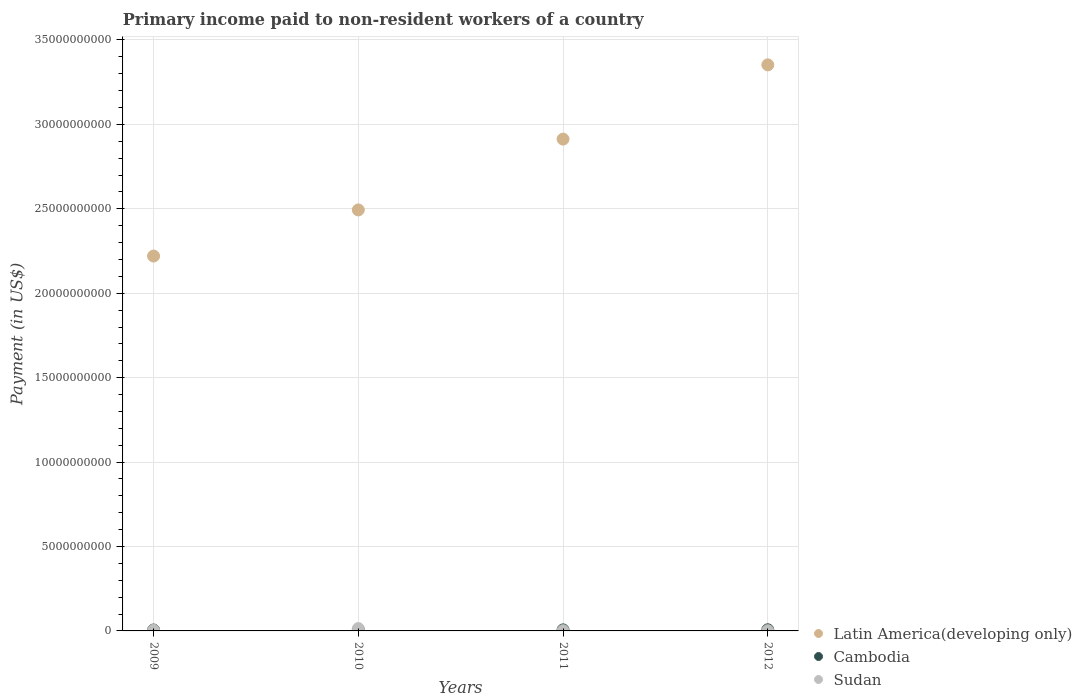Is the number of dotlines equal to the number of legend labels?
Ensure brevity in your answer.  Yes. What is the amount paid to workers in Sudan in 2011?
Keep it short and to the point. 1.35e+07. Across all years, what is the maximum amount paid to workers in Sudan?
Ensure brevity in your answer.  1.39e+08. Across all years, what is the minimum amount paid to workers in Cambodia?
Your answer should be very brief. 5.55e+07. What is the total amount paid to workers in Sudan in the graph?
Offer a very short reply. 2.03e+08. What is the difference between the amount paid to workers in Sudan in 2009 and that in 2010?
Keep it short and to the point. -1.02e+08. What is the difference between the amount paid to workers in Cambodia in 2010 and the amount paid to workers in Sudan in 2012?
Give a very brief answer. 4.44e+07. What is the average amount paid to workers in Cambodia per year?
Make the answer very short. 6.08e+07. In the year 2010, what is the difference between the amount paid to workers in Sudan and amount paid to workers in Latin America(developing only)?
Ensure brevity in your answer.  -2.48e+1. In how many years, is the amount paid to workers in Sudan greater than 9000000000 US$?
Your answer should be compact. 0. What is the ratio of the amount paid to workers in Cambodia in 2010 to that in 2011?
Provide a succinct answer. 0.96. Is the amount paid to workers in Cambodia in 2009 less than that in 2011?
Offer a very short reply. Yes. What is the difference between the highest and the second highest amount paid to workers in Sudan?
Your answer should be very brief. 1.02e+08. What is the difference between the highest and the lowest amount paid to workers in Sudan?
Give a very brief answer. 1.25e+08. Does the amount paid to workers in Sudan monotonically increase over the years?
Provide a short and direct response. No. How many dotlines are there?
Your answer should be compact. 3. What is the difference between two consecutive major ticks on the Y-axis?
Your response must be concise. 5.00e+09. Are the values on the major ticks of Y-axis written in scientific E-notation?
Offer a terse response. No. Does the graph contain any zero values?
Your response must be concise. No. Where does the legend appear in the graph?
Keep it short and to the point. Bottom right. How are the legend labels stacked?
Offer a very short reply. Vertical. What is the title of the graph?
Make the answer very short. Primary income paid to non-resident workers of a country. What is the label or title of the X-axis?
Make the answer very short. Years. What is the label or title of the Y-axis?
Offer a very short reply. Payment (in US$). What is the Payment (in US$) of Latin America(developing only) in 2009?
Keep it short and to the point. 2.22e+1. What is the Payment (in US$) in Cambodia in 2009?
Offer a terse response. 5.55e+07. What is the Payment (in US$) of Sudan in 2009?
Ensure brevity in your answer.  3.67e+07. What is the Payment (in US$) of Latin America(developing only) in 2010?
Offer a very short reply. 2.49e+1. What is the Payment (in US$) of Cambodia in 2010?
Make the answer very short. 5.87e+07. What is the Payment (in US$) of Sudan in 2010?
Your response must be concise. 1.39e+08. What is the Payment (in US$) in Latin America(developing only) in 2011?
Give a very brief answer. 2.91e+1. What is the Payment (in US$) in Cambodia in 2011?
Ensure brevity in your answer.  6.13e+07. What is the Payment (in US$) of Sudan in 2011?
Keep it short and to the point. 1.35e+07. What is the Payment (in US$) in Latin America(developing only) in 2012?
Provide a short and direct response. 3.35e+1. What is the Payment (in US$) in Cambodia in 2012?
Ensure brevity in your answer.  6.76e+07. What is the Payment (in US$) of Sudan in 2012?
Keep it short and to the point. 1.43e+07. Across all years, what is the maximum Payment (in US$) of Latin America(developing only)?
Ensure brevity in your answer.  3.35e+1. Across all years, what is the maximum Payment (in US$) of Cambodia?
Ensure brevity in your answer.  6.76e+07. Across all years, what is the maximum Payment (in US$) in Sudan?
Keep it short and to the point. 1.39e+08. Across all years, what is the minimum Payment (in US$) in Latin America(developing only)?
Provide a succinct answer. 2.22e+1. Across all years, what is the minimum Payment (in US$) in Cambodia?
Keep it short and to the point. 5.55e+07. Across all years, what is the minimum Payment (in US$) in Sudan?
Keep it short and to the point. 1.35e+07. What is the total Payment (in US$) of Latin America(developing only) in the graph?
Make the answer very short. 1.10e+11. What is the total Payment (in US$) of Cambodia in the graph?
Provide a succinct answer. 2.43e+08. What is the total Payment (in US$) of Sudan in the graph?
Offer a terse response. 2.03e+08. What is the difference between the Payment (in US$) of Latin America(developing only) in 2009 and that in 2010?
Your response must be concise. -2.73e+09. What is the difference between the Payment (in US$) of Cambodia in 2009 and that in 2010?
Provide a succinct answer. -3.15e+06. What is the difference between the Payment (in US$) of Sudan in 2009 and that in 2010?
Offer a very short reply. -1.02e+08. What is the difference between the Payment (in US$) in Latin America(developing only) in 2009 and that in 2011?
Offer a terse response. -6.93e+09. What is the difference between the Payment (in US$) in Cambodia in 2009 and that in 2011?
Offer a very short reply. -5.77e+06. What is the difference between the Payment (in US$) of Sudan in 2009 and that in 2011?
Your response must be concise. 2.32e+07. What is the difference between the Payment (in US$) of Latin America(developing only) in 2009 and that in 2012?
Your answer should be compact. -1.13e+1. What is the difference between the Payment (in US$) in Cambodia in 2009 and that in 2012?
Keep it short and to the point. -1.21e+07. What is the difference between the Payment (in US$) of Sudan in 2009 and that in 2012?
Provide a short and direct response. 2.25e+07. What is the difference between the Payment (in US$) in Latin America(developing only) in 2010 and that in 2011?
Your answer should be compact. -4.19e+09. What is the difference between the Payment (in US$) of Cambodia in 2010 and that in 2011?
Provide a short and direct response. -2.62e+06. What is the difference between the Payment (in US$) in Sudan in 2010 and that in 2011?
Offer a very short reply. 1.25e+08. What is the difference between the Payment (in US$) of Latin America(developing only) in 2010 and that in 2012?
Your response must be concise. -8.59e+09. What is the difference between the Payment (in US$) in Cambodia in 2010 and that in 2012?
Provide a succinct answer. -8.93e+06. What is the difference between the Payment (in US$) of Sudan in 2010 and that in 2012?
Provide a short and direct response. 1.24e+08. What is the difference between the Payment (in US$) in Latin America(developing only) in 2011 and that in 2012?
Ensure brevity in your answer.  -4.40e+09. What is the difference between the Payment (in US$) in Cambodia in 2011 and that in 2012?
Keep it short and to the point. -6.31e+06. What is the difference between the Payment (in US$) in Sudan in 2011 and that in 2012?
Make the answer very short. -7.31e+05. What is the difference between the Payment (in US$) in Latin America(developing only) in 2009 and the Payment (in US$) in Cambodia in 2010?
Ensure brevity in your answer.  2.21e+1. What is the difference between the Payment (in US$) in Latin America(developing only) in 2009 and the Payment (in US$) in Sudan in 2010?
Provide a short and direct response. 2.21e+1. What is the difference between the Payment (in US$) in Cambodia in 2009 and the Payment (in US$) in Sudan in 2010?
Your answer should be very brief. -8.30e+07. What is the difference between the Payment (in US$) in Latin America(developing only) in 2009 and the Payment (in US$) in Cambodia in 2011?
Provide a succinct answer. 2.21e+1. What is the difference between the Payment (in US$) of Latin America(developing only) in 2009 and the Payment (in US$) of Sudan in 2011?
Your answer should be compact. 2.22e+1. What is the difference between the Payment (in US$) of Cambodia in 2009 and the Payment (in US$) of Sudan in 2011?
Give a very brief answer. 4.20e+07. What is the difference between the Payment (in US$) of Latin America(developing only) in 2009 and the Payment (in US$) of Cambodia in 2012?
Your answer should be very brief. 2.21e+1. What is the difference between the Payment (in US$) in Latin America(developing only) in 2009 and the Payment (in US$) in Sudan in 2012?
Your answer should be compact. 2.22e+1. What is the difference between the Payment (in US$) in Cambodia in 2009 and the Payment (in US$) in Sudan in 2012?
Your answer should be compact. 4.13e+07. What is the difference between the Payment (in US$) in Latin America(developing only) in 2010 and the Payment (in US$) in Cambodia in 2011?
Ensure brevity in your answer.  2.49e+1. What is the difference between the Payment (in US$) of Latin America(developing only) in 2010 and the Payment (in US$) of Sudan in 2011?
Your response must be concise. 2.49e+1. What is the difference between the Payment (in US$) of Cambodia in 2010 and the Payment (in US$) of Sudan in 2011?
Give a very brief answer. 4.52e+07. What is the difference between the Payment (in US$) in Latin America(developing only) in 2010 and the Payment (in US$) in Cambodia in 2012?
Make the answer very short. 2.49e+1. What is the difference between the Payment (in US$) in Latin America(developing only) in 2010 and the Payment (in US$) in Sudan in 2012?
Your answer should be very brief. 2.49e+1. What is the difference between the Payment (in US$) of Cambodia in 2010 and the Payment (in US$) of Sudan in 2012?
Offer a terse response. 4.44e+07. What is the difference between the Payment (in US$) in Latin America(developing only) in 2011 and the Payment (in US$) in Cambodia in 2012?
Give a very brief answer. 2.91e+1. What is the difference between the Payment (in US$) in Latin America(developing only) in 2011 and the Payment (in US$) in Sudan in 2012?
Make the answer very short. 2.91e+1. What is the difference between the Payment (in US$) of Cambodia in 2011 and the Payment (in US$) of Sudan in 2012?
Give a very brief answer. 4.70e+07. What is the average Payment (in US$) in Latin America(developing only) per year?
Ensure brevity in your answer.  2.74e+1. What is the average Payment (in US$) in Cambodia per year?
Keep it short and to the point. 6.08e+07. What is the average Payment (in US$) in Sudan per year?
Keep it short and to the point. 5.08e+07. In the year 2009, what is the difference between the Payment (in US$) of Latin America(developing only) and Payment (in US$) of Cambodia?
Make the answer very short. 2.21e+1. In the year 2009, what is the difference between the Payment (in US$) in Latin America(developing only) and Payment (in US$) in Sudan?
Keep it short and to the point. 2.22e+1. In the year 2009, what is the difference between the Payment (in US$) in Cambodia and Payment (in US$) in Sudan?
Make the answer very short. 1.88e+07. In the year 2010, what is the difference between the Payment (in US$) in Latin America(developing only) and Payment (in US$) in Cambodia?
Provide a short and direct response. 2.49e+1. In the year 2010, what is the difference between the Payment (in US$) in Latin America(developing only) and Payment (in US$) in Sudan?
Make the answer very short. 2.48e+1. In the year 2010, what is the difference between the Payment (in US$) in Cambodia and Payment (in US$) in Sudan?
Ensure brevity in your answer.  -7.99e+07. In the year 2011, what is the difference between the Payment (in US$) of Latin America(developing only) and Payment (in US$) of Cambodia?
Your answer should be compact. 2.91e+1. In the year 2011, what is the difference between the Payment (in US$) in Latin America(developing only) and Payment (in US$) in Sudan?
Provide a succinct answer. 2.91e+1. In the year 2011, what is the difference between the Payment (in US$) in Cambodia and Payment (in US$) in Sudan?
Offer a terse response. 4.78e+07. In the year 2012, what is the difference between the Payment (in US$) of Latin America(developing only) and Payment (in US$) of Cambodia?
Make the answer very short. 3.35e+1. In the year 2012, what is the difference between the Payment (in US$) of Latin America(developing only) and Payment (in US$) of Sudan?
Ensure brevity in your answer.  3.35e+1. In the year 2012, what is the difference between the Payment (in US$) of Cambodia and Payment (in US$) of Sudan?
Provide a succinct answer. 5.33e+07. What is the ratio of the Payment (in US$) in Latin America(developing only) in 2009 to that in 2010?
Make the answer very short. 0.89. What is the ratio of the Payment (in US$) of Cambodia in 2009 to that in 2010?
Provide a short and direct response. 0.95. What is the ratio of the Payment (in US$) in Sudan in 2009 to that in 2010?
Your response must be concise. 0.27. What is the ratio of the Payment (in US$) of Latin America(developing only) in 2009 to that in 2011?
Provide a succinct answer. 0.76. What is the ratio of the Payment (in US$) of Cambodia in 2009 to that in 2011?
Keep it short and to the point. 0.91. What is the ratio of the Payment (in US$) of Sudan in 2009 to that in 2011?
Your answer should be compact. 2.71. What is the ratio of the Payment (in US$) of Latin America(developing only) in 2009 to that in 2012?
Offer a terse response. 0.66. What is the ratio of the Payment (in US$) in Cambodia in 2009 to that in 2012?
Offer a very short reply. 0.82. What is the ratio of the Payment (in US$) of Sudan in 2009 to that in 2012?
Keep it short and to the point. 2.57. What is the ratio of the Payment (in US$) in Latin America(developing only) in 2010 to that in 2011?
Offer a very short reply. 0.86. What is the ratio of the Payment (in US$) in Cambodia in 2010 to that in 2011?
Provide a succinct answer. 0.96. What is the ratio of the Payment (in US$) in Sudan in 2010 to that in 2011?
Offer a very short reply. 10.23. What is the ratio of the Payment (in US$) in Latin America(developing only) in 2010 to that in 2012?
Your answer should be compact. 0.74. What is the ratio of the Payment (in US$) of Cambodia in 2010 to that in 2012?
Ensure brevity in your answer.  0.87. What is the ratio of the Payment (in US$) in Sudan in 2010 to that in 2012?
Provide a short and direct response. 9.71. What is the ratio of the Payment (in US$) of Latin America(developing only) in 2011 to that in 2012?
Offer a terse response. 0.87. What is the ratio of the Payment (in US$) of Cambodia in 2011 to that in 2012?
Your answer should be very brief. 0.91. What is the ratio of the Payment (in US$) in Sudan in 2011 to that in 2012?
Your response must be concise. 0.95. What is the difference between the highest and the second highest Payment (in US$) of Latin America(developing only)?
Offer a very short reply. 4.40e+09. What is the difference between the highest and the second highest Payment (in US$) in Cambodia?
Keep it short and to the point. 6.31e+06. What is the difference between the highest and the second highest Payment (in US$) of Sudan?
Make the answer very short. 1.02e+08. What is the difference between the highest and the lowest Payment (in US$) in Latin America(developing only)?
Ensure brevity in your answer.  1.13e+1. What is the difference between the highest and the lowest Payment (in US$) of Cambodia?
Keep it short and to the point. 1.21e+07. What is the difference between the highest and the lowest Payment (in US$) of Sudan?
Give a very brief answer. 1.25e+08. 